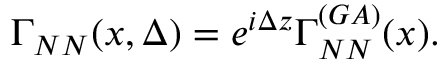Convert formula to latex. <formula><loc_0><loc_0><loc_500><loc_500>\Gamma _ { N N } ( x , \Delta ) = e ^ { i \Delta z } \Gamma _ { N N } ^ { ( G A ) } ( x ) .</formula> 